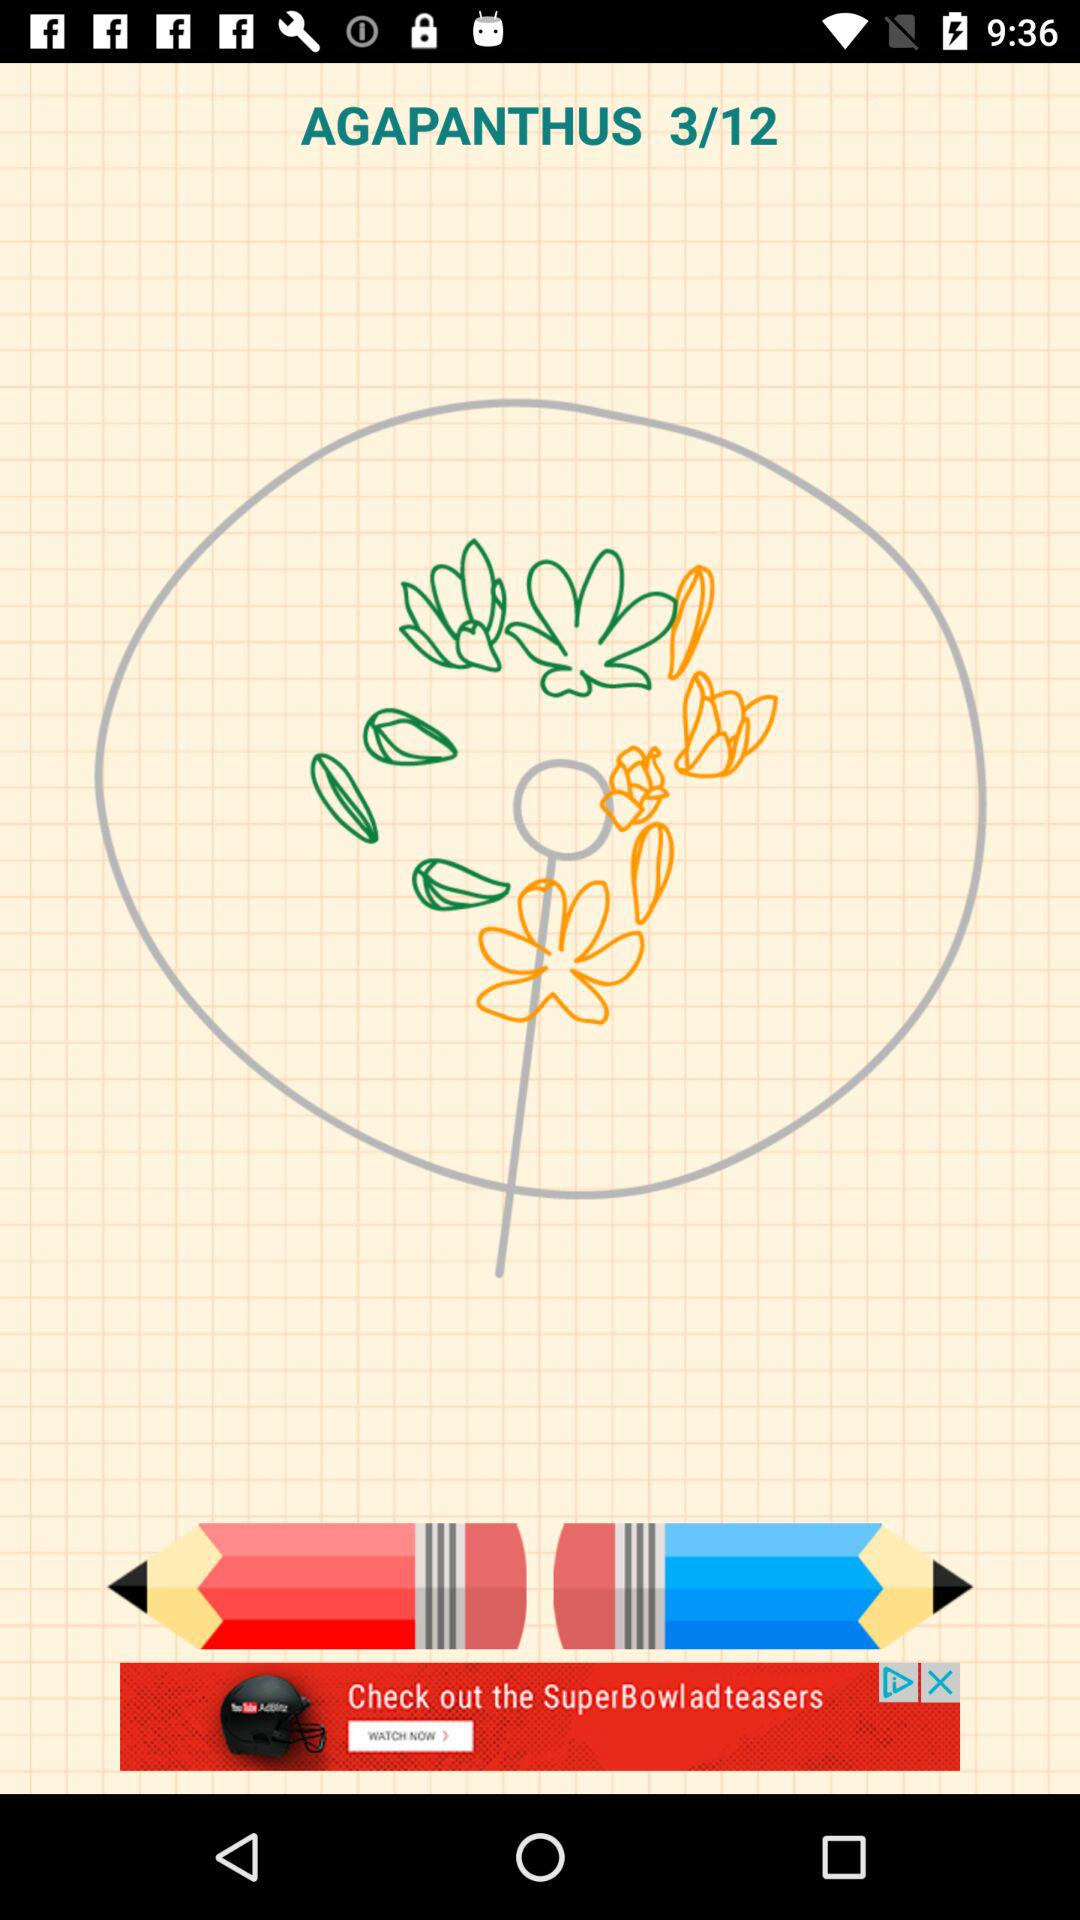What's the current step number? The current step number is 3. 